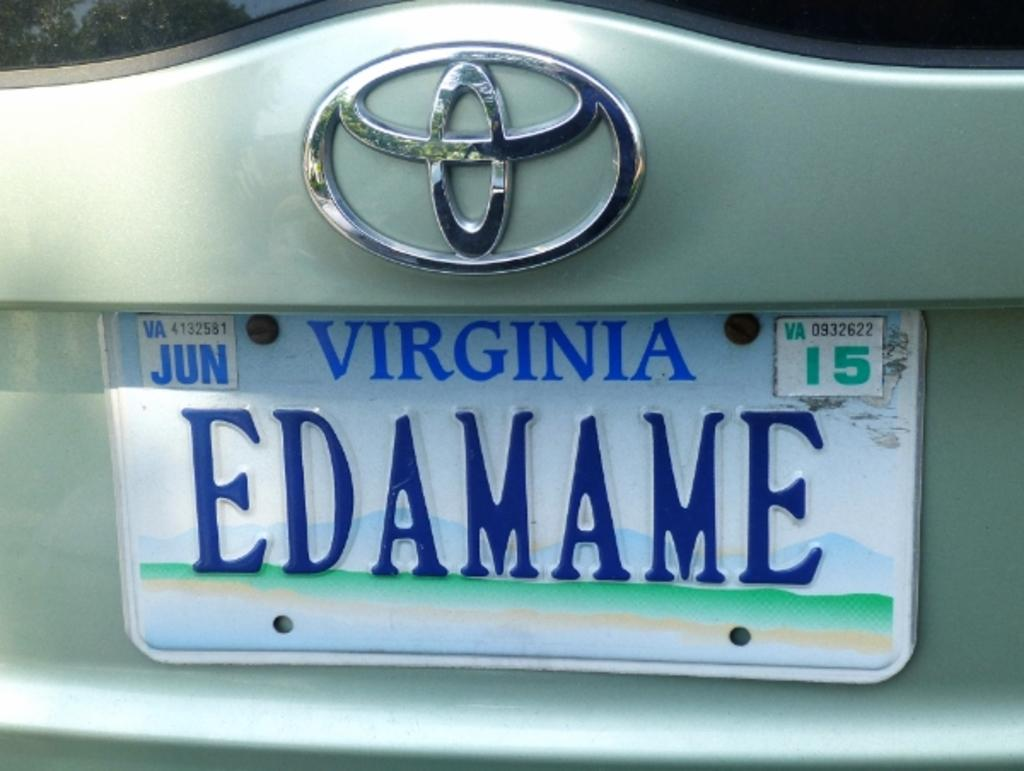<image>
Present a compact description of the photo's key features. A green Toyota has the license plate Edamame. 